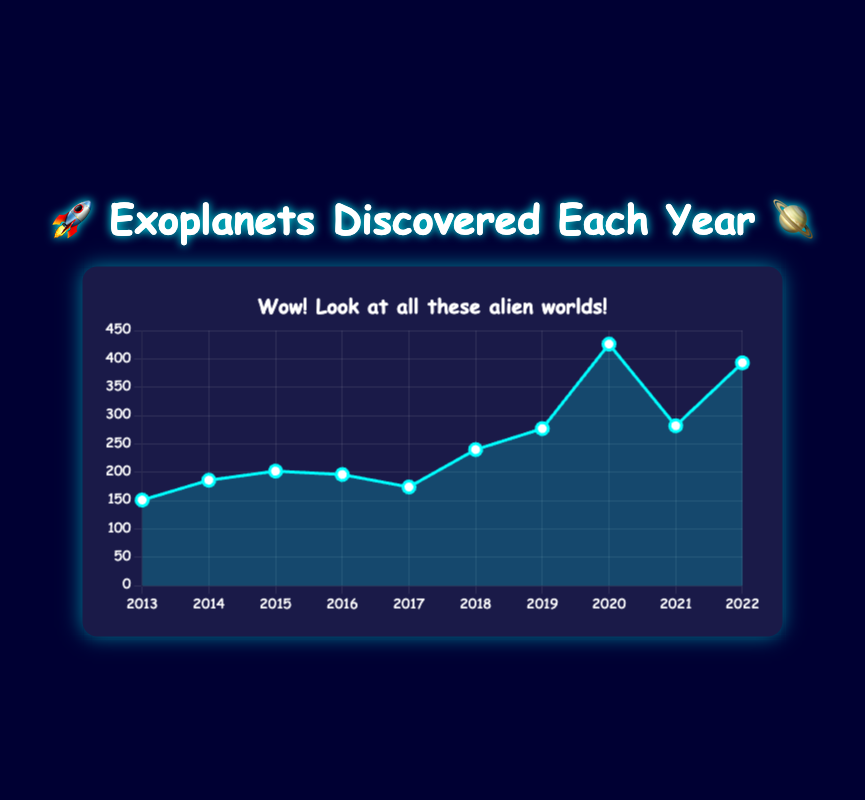What's the total number of exoplanets discovered from 2013 to 2015? Add the numbers of exoplanets discovered each year from 2013 to 2015: 151 (2013) + 186 (2014) + 202 (2015) = 539
Answer: 539 Which year had the highest number of exoplanets discovered? Look for the year with the highest data point on the graph. The highest data point is in 2020, with 426 exoplanets discovered
Answer: 2020 How many more exoplanets were discovered in 2022 than in 2019? Subtract the number of exoplanets discovered in 2019 from those in 2022: 393 - 277 = 116
Answer: 116 What is the average number of exoplanets discovered per year from 2013 to 2022? Sum up the total number of exoplanets discovered each year from 2013 to 2022, then divide by the number of years (10). The total is 151 + 186 + 202 + 196 + 174 + 240 + 277 + 426 + 282 + 393 = 2527. Divide 2527 by 10, which gives the average: 2527 / 10 = 252.7
Answer: 252.7 Which year had fewer exoplanets discovered: 2017 or 2018? Compare the data points for 2017 and 2018. In 2017, there were 174 exoplanets discovered, and in 2018, there were 240. 174 is less than 240
Answer: 2017 How did the number of exoplanets discovered change from 2020 to 2021? Compare the data points for 2020 and 2021. In 2020, there were 426 exoplanets discovered, while in 2021 there were 282. The number decreased by 426 - 282 = 144
Answer: Decreased by 144 By how much did the number of exoplanets discovered increase from 2017 to 2018? Subtract the number of exoplanets discovered in 2017 from those in 2018: 240 - 174 = 66
Answer: 66 What is the median number of exoplanets discovered per year from 2013 to 2022? List the numbers in ascending order: 151, 174, 186, 196, 202, 240, 277, 282, 393, 426. The median is the average of the 5th and 6th values: (202 + 240) / 2 = 221
Answer: 221 Did more exoplanets get discovered in the first half (2013-2017) or the second half (2018-2022) of the decade? Add the number of exoplanets discovered from 2013 to 2017, then add those from 2018 to 2022. First half: 151 + 186 + 202 + 196 + 174 = 909. Second half: 240 + 277 + 426 + 282 + 393 = 1618. Compare 909 and 1618; 1618 is more
Answer: Second half 